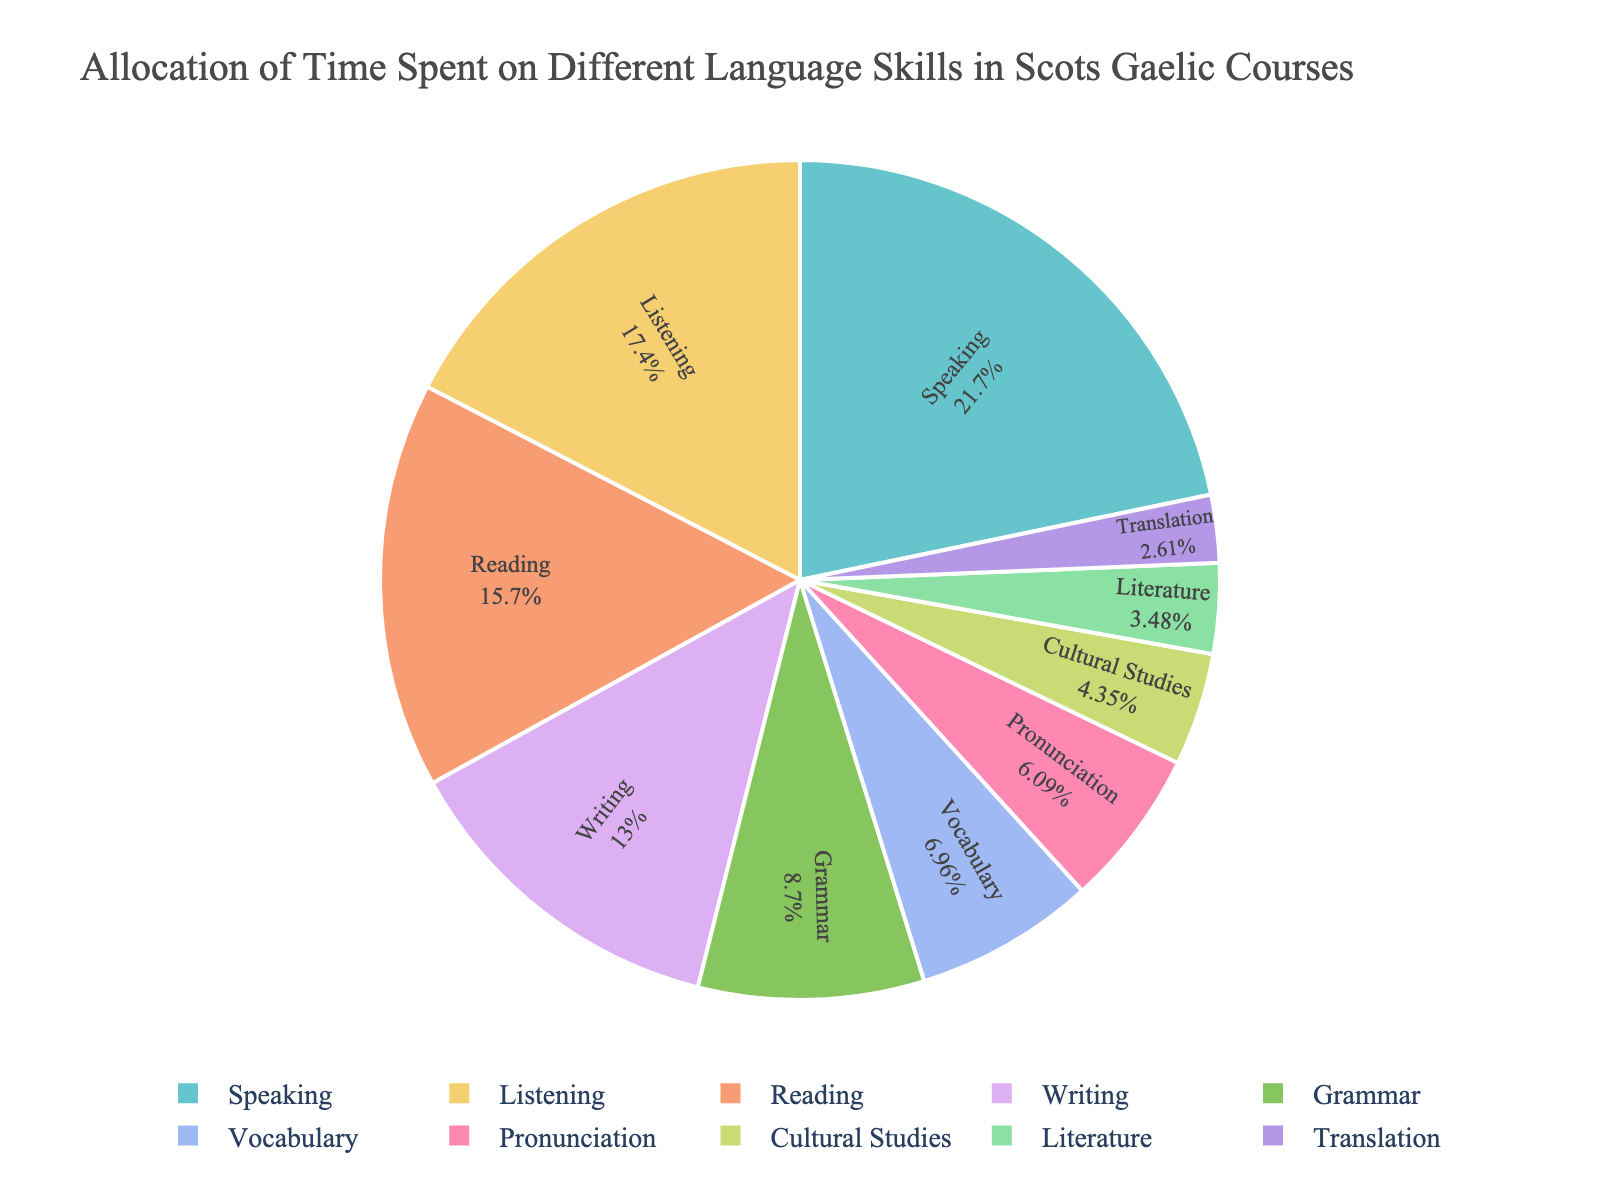What skill has the highest allocation of time? To find the skill with the highest allocation of time, look for the slice with the largest percentage value in the pie chart.
Answer: Speaking What is the total percentage of time allocated to Grammar and Vocabulary combined? Add the percentage values of Grammar (10%) and Vocabulary (8%): 10% + 8% = 18%.
Answer: 18% Which skill has a lower percentage allocation, Reading or Writing? Compare the percentage values for Reading (18%) and Writing (15%); Writing has a smaller percentage.
Answer: Writing What is the difference in percentage between Listening and Pronunciation? Subtract the percentage value of Pronunciation (7%) from that of Listening (20%): 20% - 7% = 13%.
Answer: 13% How much time is allocated to Translation relative to Literature? Find the ratio of the percentage allocated to Translation (3%) to that of Literature (4%): 3% / 4% = 0.75.
Answer: 0.75 Considering the visually smallest slices, which skill is allocated the least amount of time? Identify the smallest visible slice in the pie chart, which corresponds to the skill with the smallest percentage.
Answer: Translation How does the time allocated to Cultural Studies compare with Writing? Compare the percentage values for Cultural Studies (5%) and Writing (15%); Writing has a higher percentage.
Answer: Writing has a higher percentage If time spent on Grammar was doubled, what would its new percentage be? Double the current percentage value for Grammar (10%): 10% * 2 = 20%.
Answer: 20% Which skills account for just under half of the total time allocated? Combine the percentage values of skills, stopping just under 50%. Speaking (25%) plus Listening (20%) equals 45%.
Answer: Speaking and Listening 